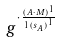<formula> <loc_0><loc_0><loc_500><loc_500>g ^ { \cdot \frac { ( A \cdot M ) ^ { 1 } } { 1 { ( s _ { A } ) } ^ { 1 } } }</formula> 